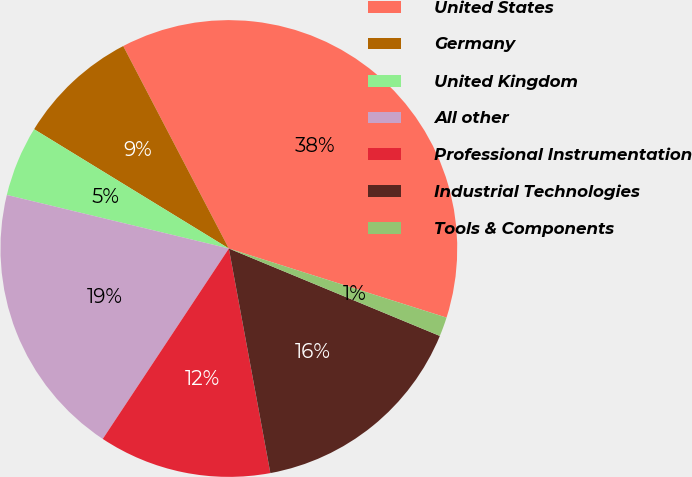Convert chart. <chart><loc_0><loc_0><loc_500><loc_500><pie_chart><fcel>United States<fcel>Germany<fcel>United Kingdom<fcel>All other<fcel>Professional Instrumentation<fcel>Industrial Technologies<fcel>Tools & Components<nl><fcel>37.55%<fcel>8.6%<fcel>4.98%<fcel>19.46%<fcel>12.22%<fcel>15.84%<fcel>1.36%<nl></chart> 